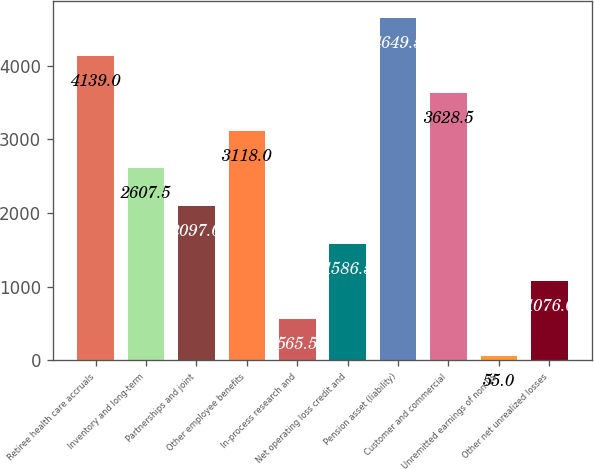Convert chart to OTSL. <chart><loc_0><loc_0><loc_500><loc_500><bar_chart><fcel>Retiree health care accruals<fcel>Inventory and long-term<fcel>Partnerships and joint<fcel>Other employee benefits<fcel>In-process research and<fcel>Net operating loss credit and<fcel>Pension asset (liability)<fcel>Customer and commercial<fcel>Unremitted earnings of non-US<fcel>Other net unrealized losses<nl><fcel>4139<fcel>2607.5<fcel>2097<fcel>3118<fcel>565.5<fcel>1586.5<fcel>4649.5<fcel>3628.5<fcel>55<fcel>1076<nl></chart> 